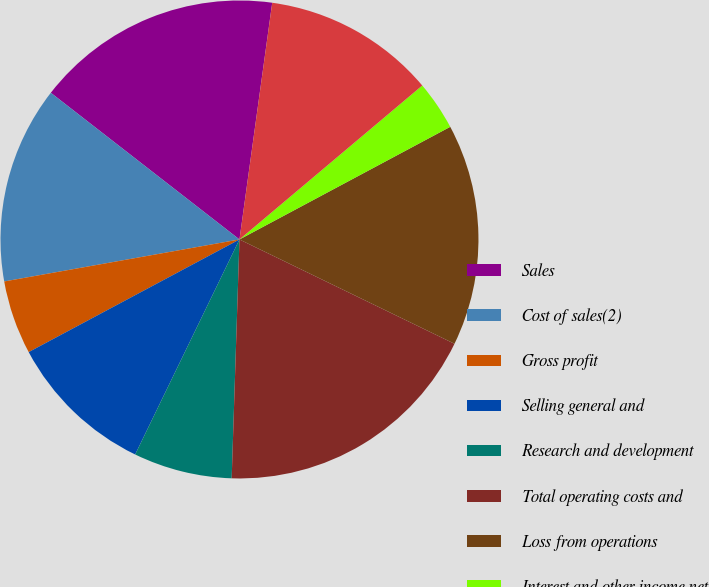Convert chart to OTSL. <chart><loc_0><loc_0><loc_500><loc_500><pie_chart><fcel>Sales<fcel>Cost of sales(2)<fcel>Gross profit<fcel>Selling general and<fcel>Research and development<fcel>Total operating costs and<fcel>Loss from operations<fcel>Interest and other income net<fcel>Net loss<fcel>Basic and diluted net loss per<nl><fcel>16.67%<fcel>13.33%<fcel>5.0%<fcel>10.0%<fcel>6.67%<fcel>18.33%<fcel>15.0%<fcel>3.33%<fcel>11.67%<fcel>0.0%<nl></chart> 